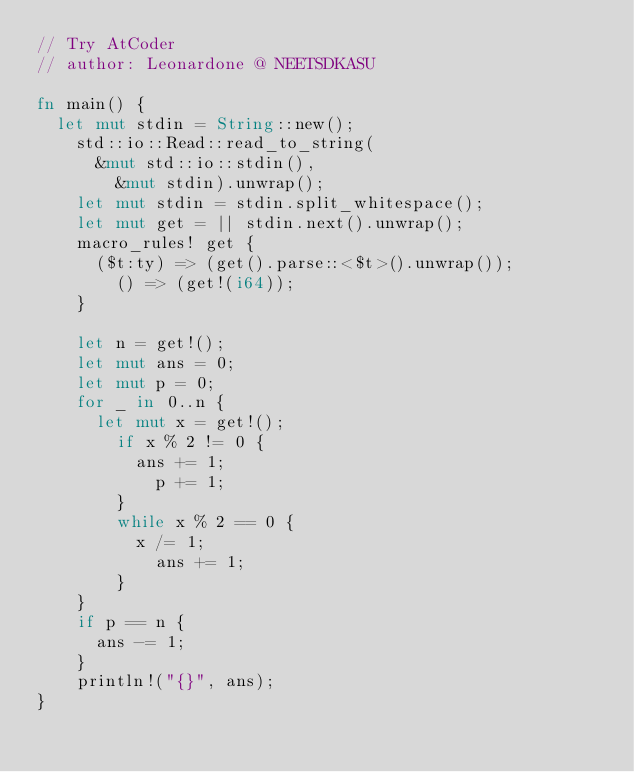<code> <loc_0><loc_0><loc_500><loc_500><_Rust_>// Try AtCoder
// author: Leonardone @ NEETSDKASU

fn main() {
	let mut stdin = String::new();
    std::io::Read::read_to_string(
    	&mut std::io::stdin(),
        &mut stdin).unwrap();
    let mut stdin = stdin.split_whitespace();
    let mut get = || stdin.next().unwrap();
    macro_rules! get {
    	($t:ty) => (get().parse::<$t>().unwrap());
        () => (get!(i64));
    }
    
    let n = get!();
    let mut ans = 0;
    let mut p = 0;
    for _ in 0..n {
    	let mut x = get!();
        if x % 2 != 0 {
        	ans += 1;
            p += 1;
        }
        while x % 2 == 0 {
        	x /= 1;
            ans += 1;
        }
    }
    if p == n {
    	ans -= 1;
    }
    println!("{}", ans);
}</code> 